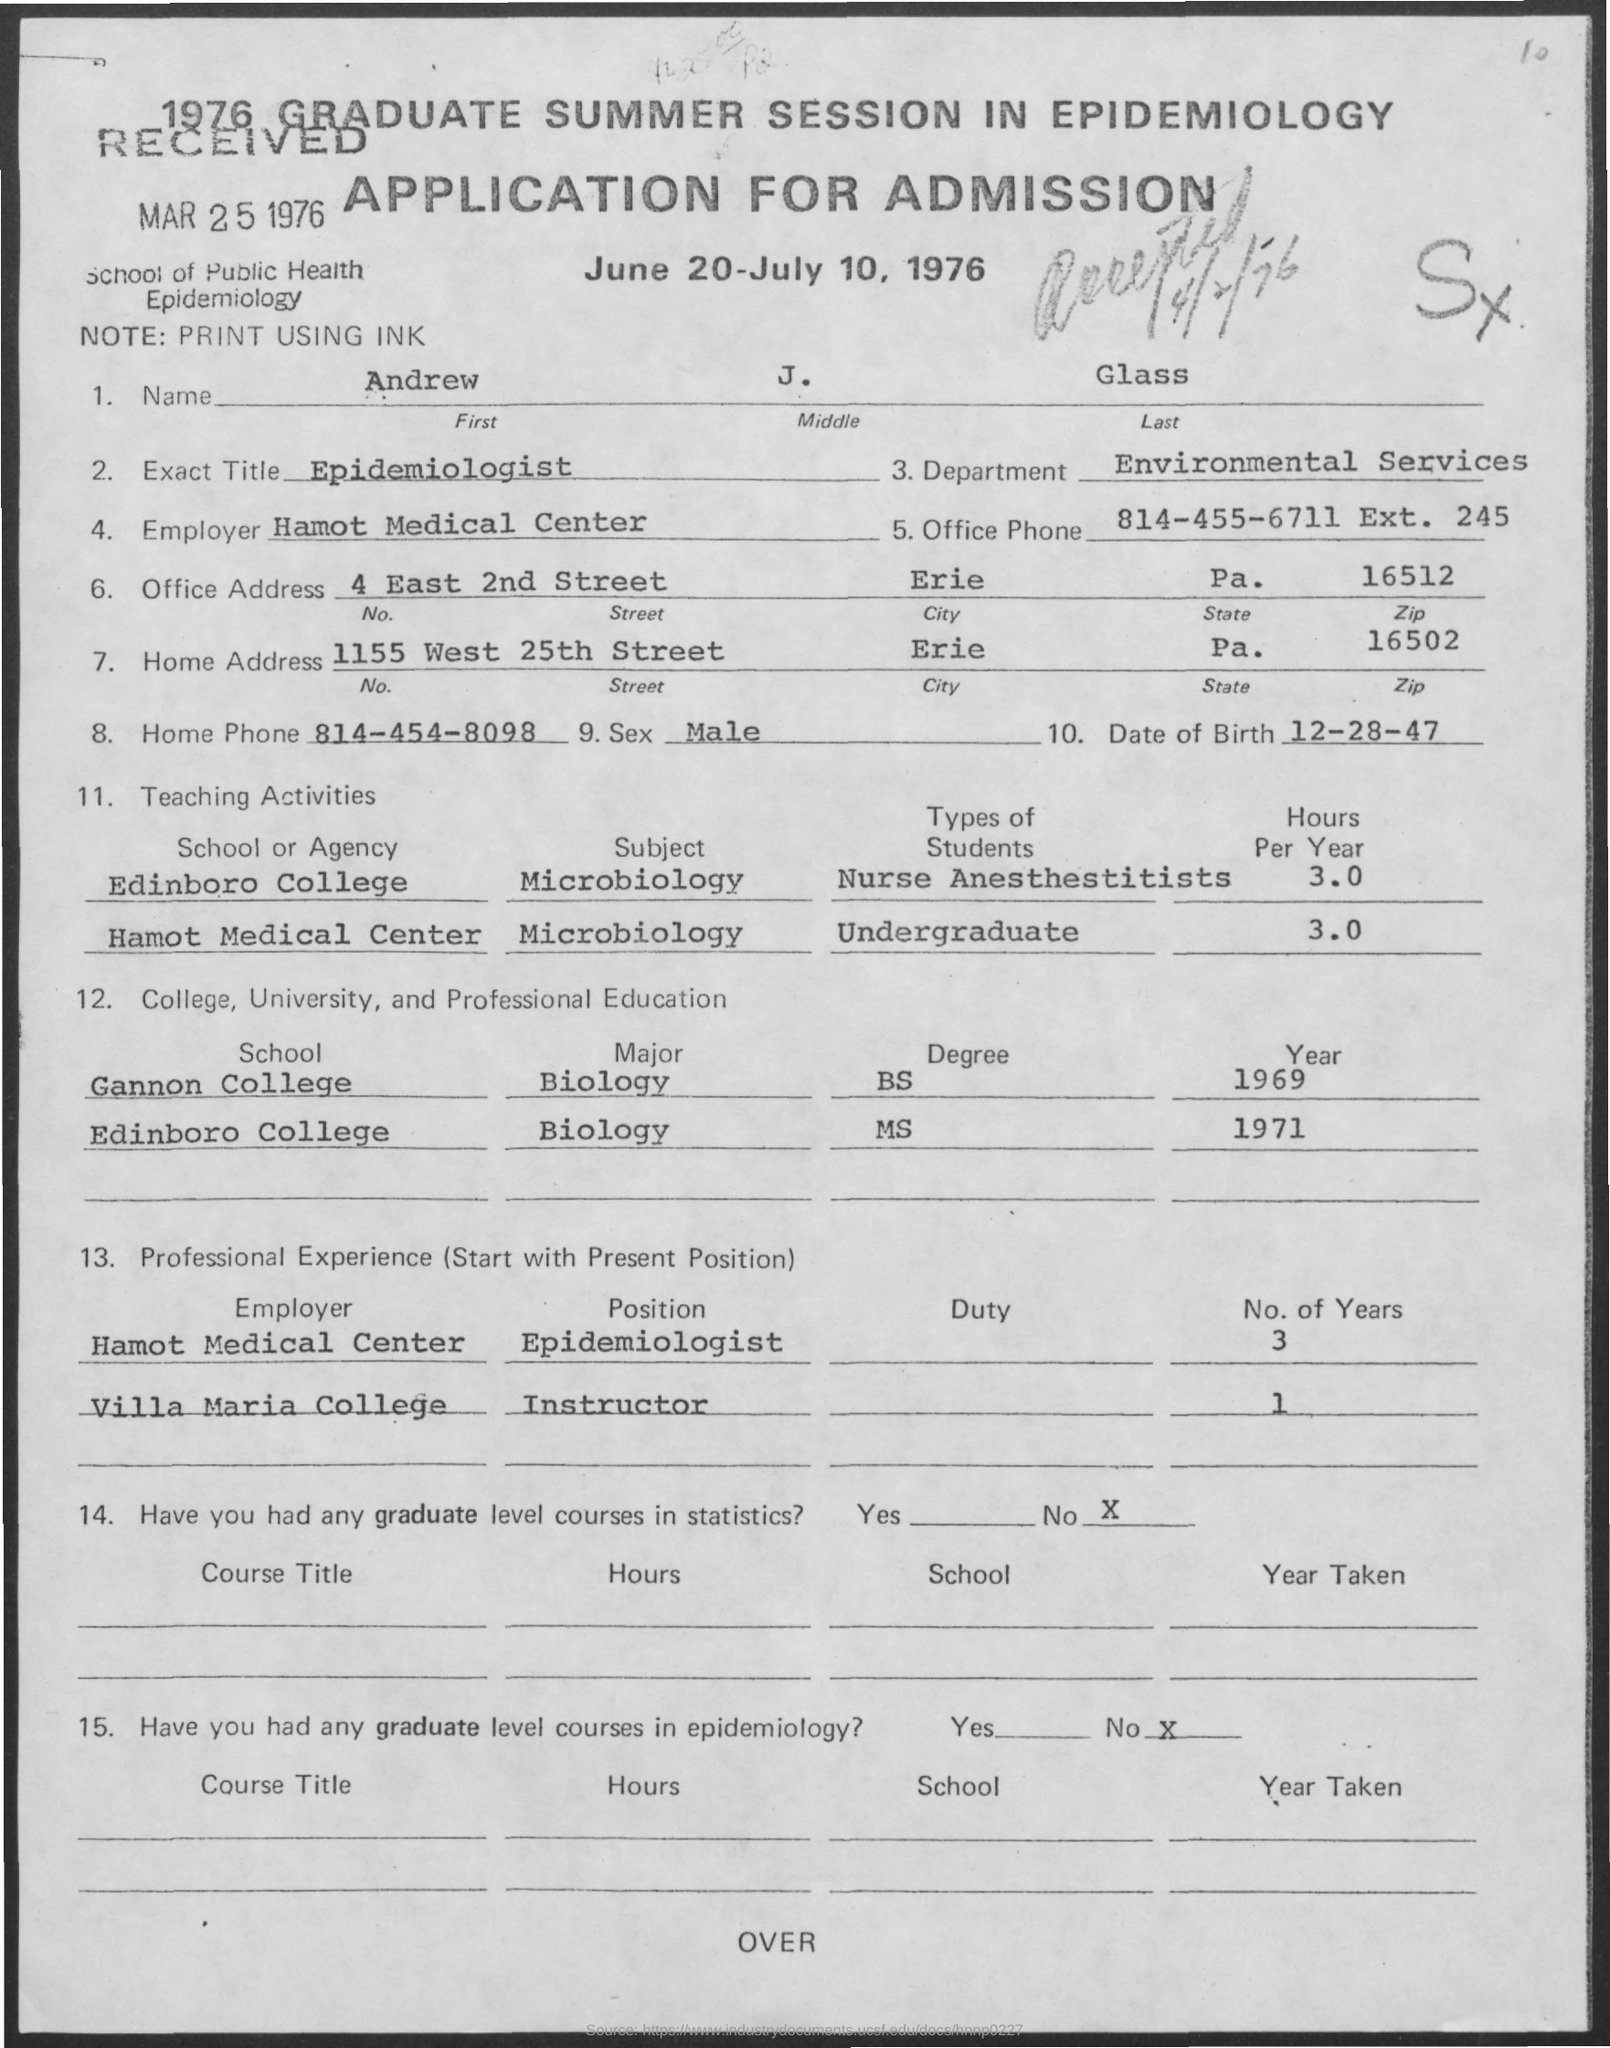What is written in the Exact Title ?
Offer a terse response. Epidemiologist. What is the Date of Birth of Andrew ?
Provide a short and direct response. 12-28-47. What is the Zip Code for Office Address ?
Make the answer very short. 16512. What is the Home Phone Number ?
Offer a very short reply. 814-454-8098. 